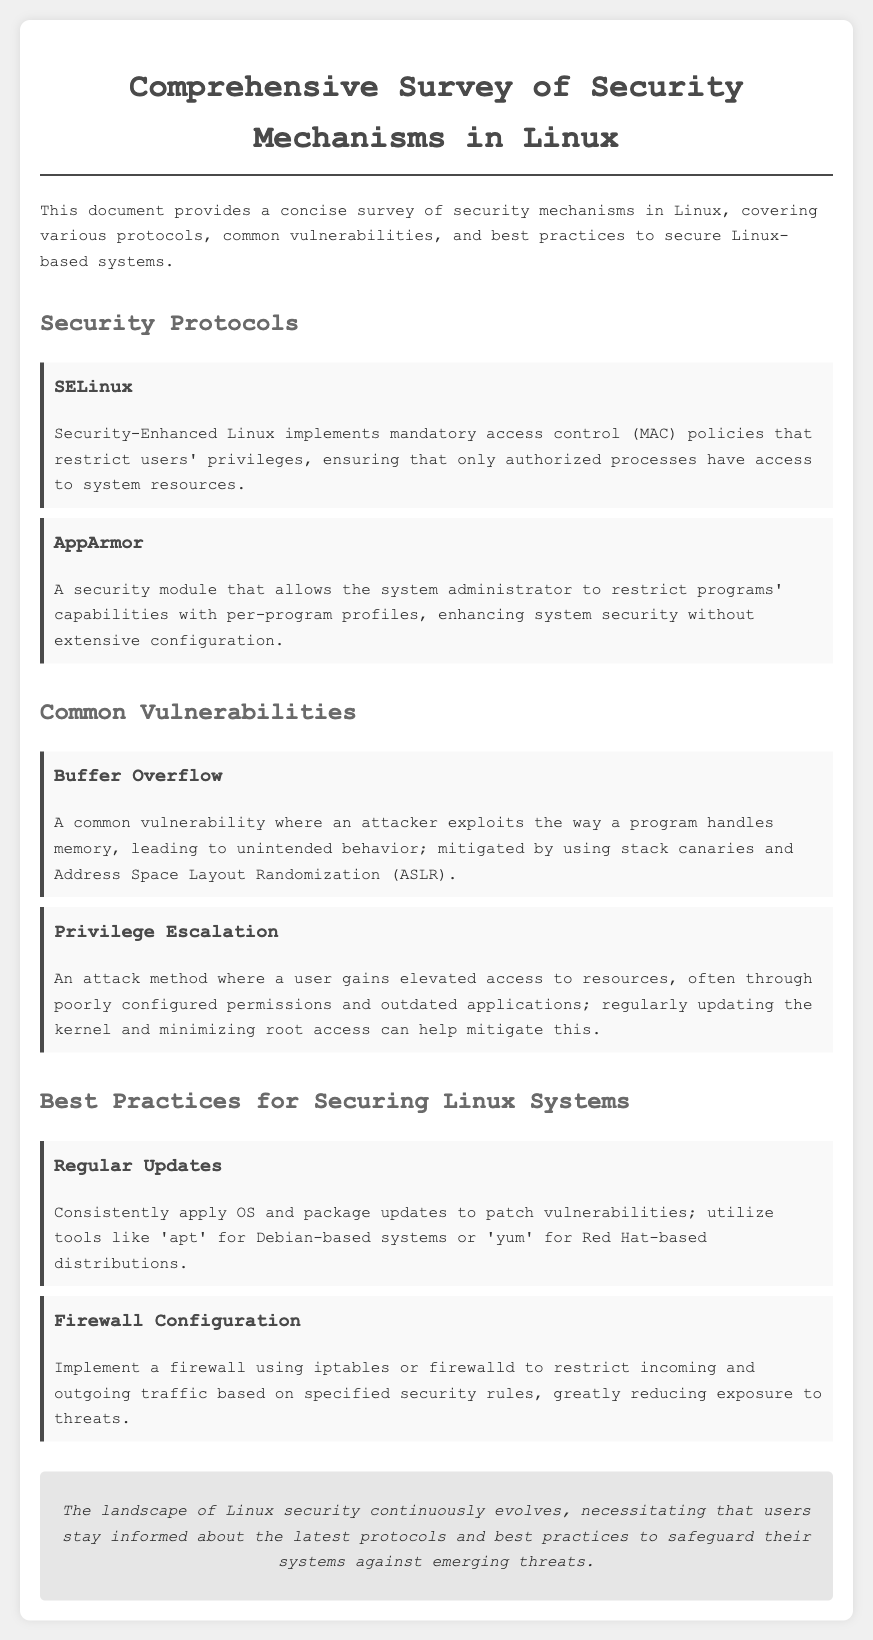What security mechanism implements mandatory access control? SELinux is mentioned as implementing mandatory access control (MAC) policies in the document.
Answer: SELinux What common vulnerability is mitigated by stack canaries? The document states that buffer overflow vulnerabilities are mitigated by using stack canaries.
Answer: Buffer Overflow What is a recommended tool for applying updates in Debian-based systems? The document suggests using 'apt' as a tool for applying updates in Debian-based systems.
Answer: apt How many security protocols are listed in the document? The document lists two security protocols in the Security Protocols section.
Answer: 2 What practice can help minimize the risk of privilege escalation attacks? The document indicates that regularly updating the kernel can help mitigate risks of privilege escalation.
Answer: Regularly updating the kernel What security enhancement does AppArmor provide? The document describes AppArmor as allowing administrators to restrict programs' capabilities with per-program profiles.
Answer: Restrict programs' capabilities What is a critical function of a firewall as mentioned in the document? The document states that a firewall configuration is meant to restrict incoming and outgoing traffic based on specified security rules.
Answer: Restrict incoming and outgoing traffic What is the conclusion regarding Linux security? The conclusion emphasizes the need for users to stay informed about the latest protocols and best practices for security.
Answer: Stay informed 